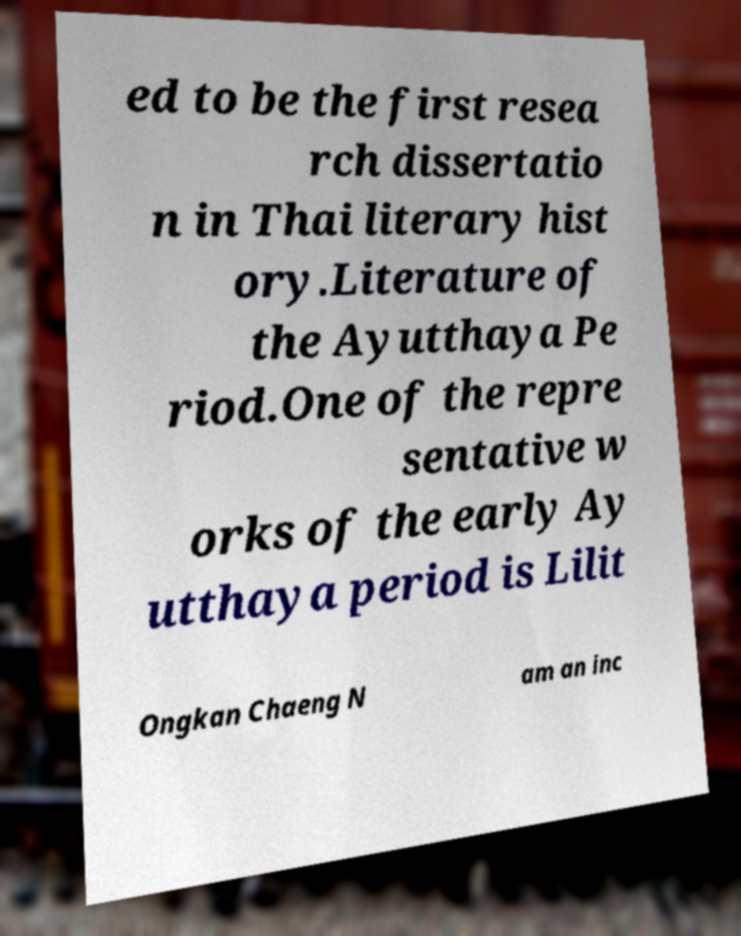What messages or text are displayed in this image? I need them in a readable, typed format. ed to be the first resea rch dissertatio n in Thai literary hist ory.Literature of the Ayutthaya Pe riod.One of the repre sentative w orks of the early Ay utthaya period is Lilit Ongkan Chaeng N am an inc 